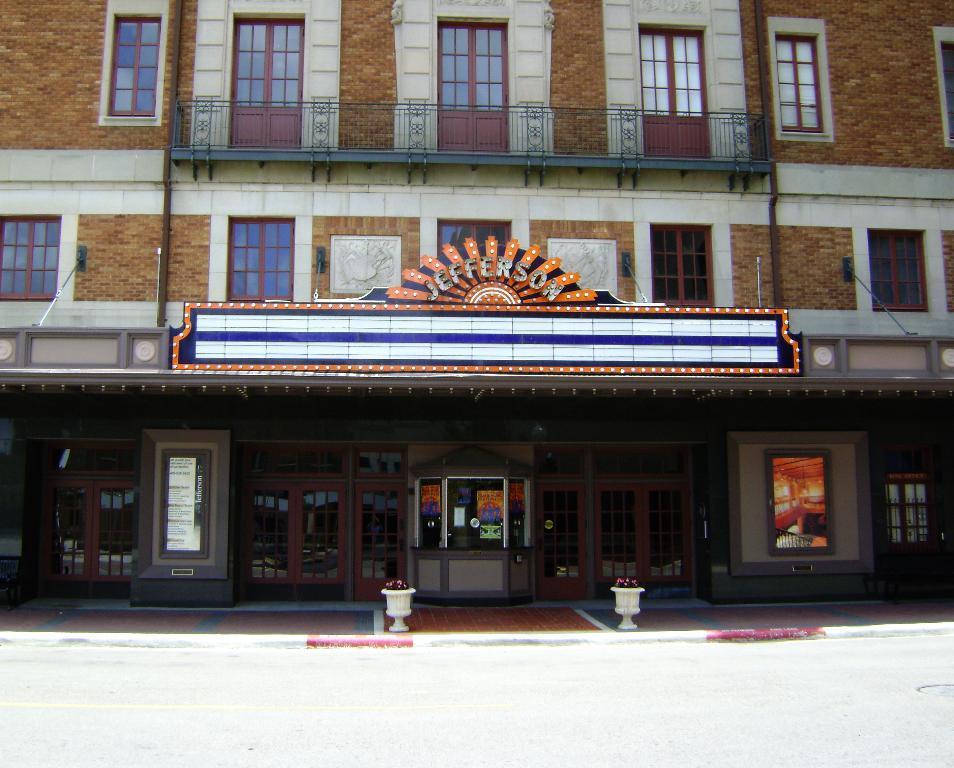How would you summarize this image in a sentence or two? This image is taken outdoors. At the bottom of the image there is a road. In the middle of the image there is a building with walls, windows, doors, a railing and a balcony. There is a board with a text on it and there are a few rope lights. There are a few boards with a text on them. There are two pots with plants. 